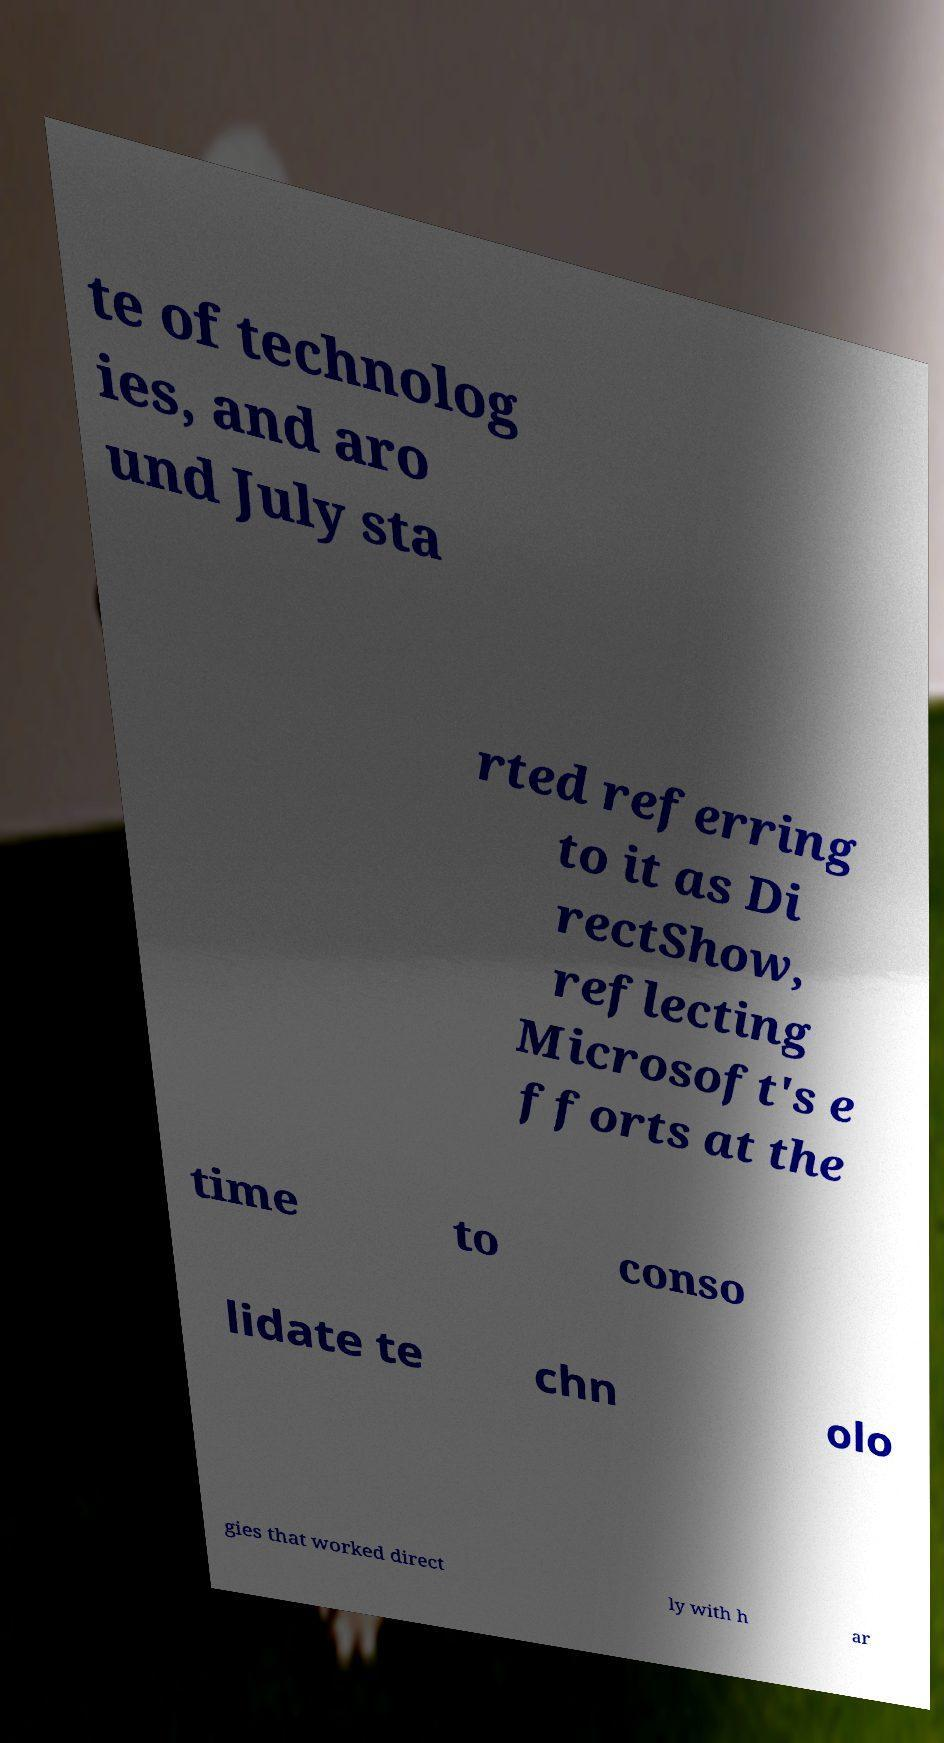For documentation purposes, I need the text within this image transcribed. Could you provide that? te of technolog ies, and aro und July sta rted referring to it as Di rectShow, reflecting Microsoft's e fforts at the time to conso lidate te chn olo gies that worked direct ly with h ar 